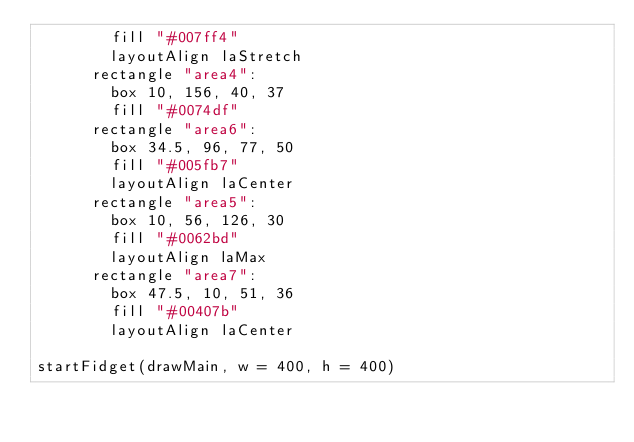Convert code to text. <code><loc_0><loc_0><loc_500><loc_500><_Nim_>        fill "#007ff4"
        layoutAlign laStretch
      rectangle "area4":
        box 10, 156, 40, 37
        fill "#0074df"
      rectangle "area6":
        box 34.5, 96, 77, 50
        fill "#005fb7"
        layoutAlign laCenter
      rectangle "area5":
        box 10, 56, 126, 30
        fill "#0062bd"
        layoutAlign laMax
      rectangle "area7":
        box 47.5, 10, 51, 36
        fill "#00407b"
        layoutAlign laCenter

startFidget(drawMain, w = 400, h = 400)
</code> 